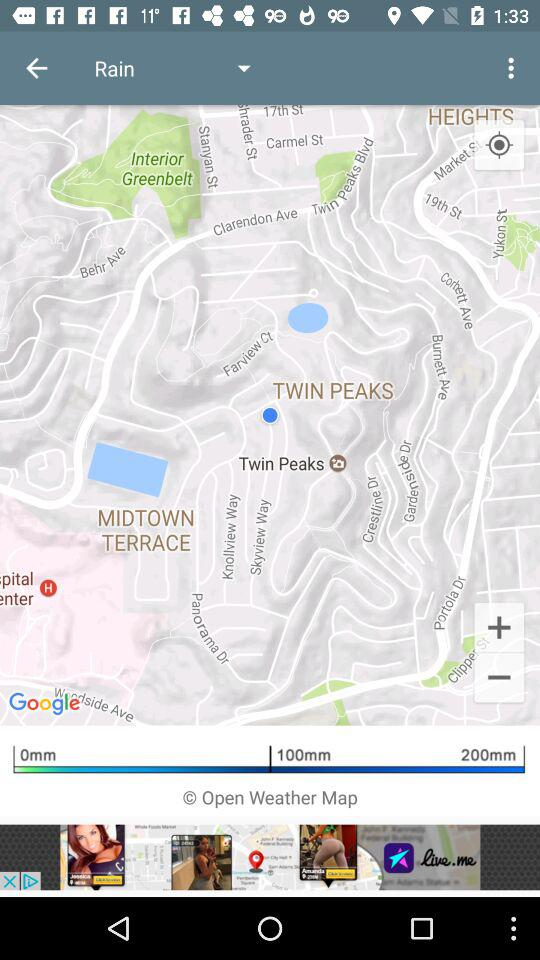How much more rain is expected in the next hour than in the last hour?
Answer the question using a single word or phrase. 100mm 